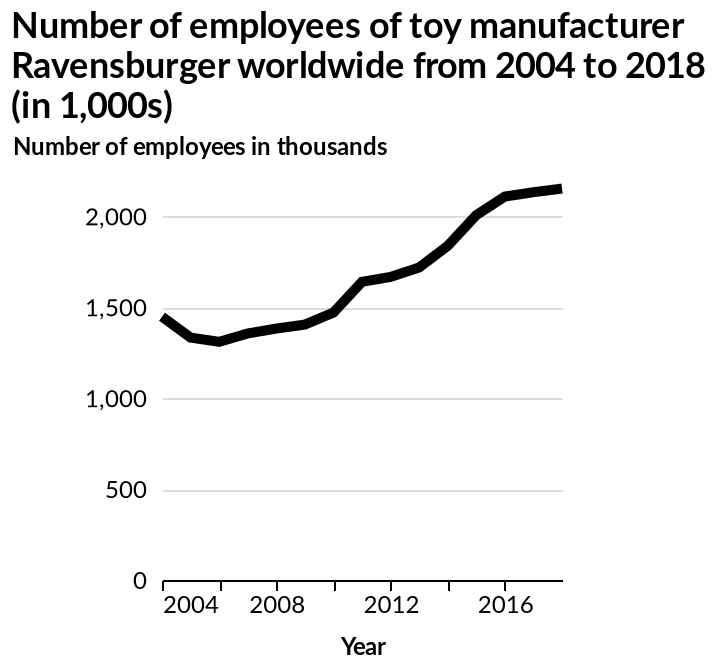<image>
What is the projected trend for the company regarding employee numbers? The trend is for the company to continue increasing employee numbers. What happened to employee numbers between 2004 and 2006? Employee numbers decreased during the period between 2004 and 2006. 